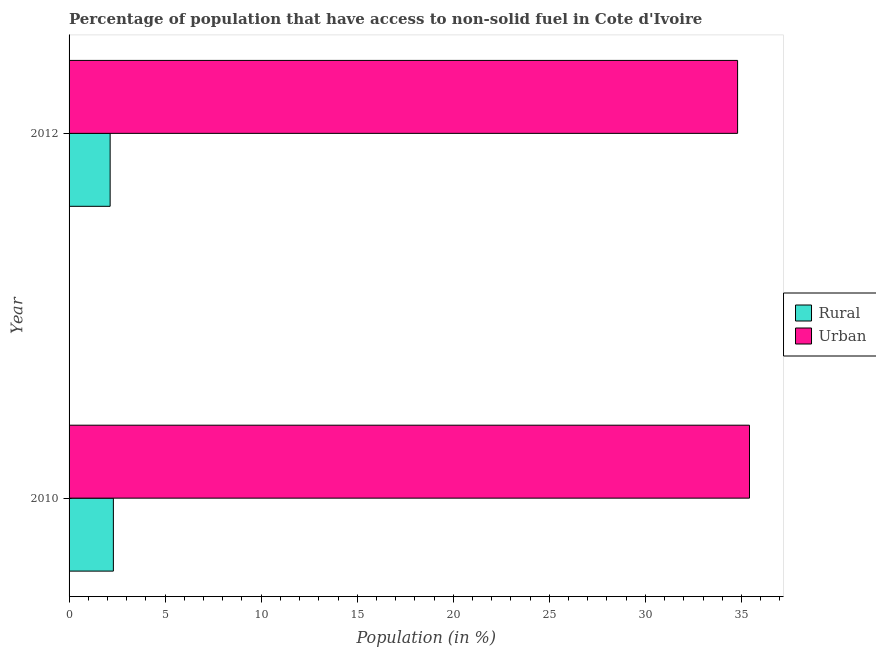Are the number of bars per tick equal to the number of legend labels?
Offer a very short reply. Yes. Are the number of bars on each tick of the Y-axis equal?
Offer a terse response. Yes. How many bars are there on the 1st tick from the top?
Keep it short and to the point. 2. How many bars are there on the 2nd tick from the bottom?
Offer a very short reply. 2. What is the label of the 2nd group of bars from the top?
Give a very brief answer. 2010. What is the urban population in 2012?
Give a very brief answer. 34.8. Across all years, what is the maximum rural population?
Ensure brevity in your answer.  2.31. Across all years, what is the minimum urban population?
Your answer should be compact. 34.8. In which year was the rural population minimum?
Provide a succinct answer. 2012. What is the total rural population in the graph?
Give a very brief answer. 4.44. What is the difference between the urban population in 2010 and that in 2012?
Make the answer very short. 0.62. What is the difference between the urban population in 2010 and the rural population in 2012?
Offer a very short reply. 33.28. What is the average urban population per year?
Provide a short and direct response. 35.11. In the year 2012, what is the difference between the rural population and urban population?
Your answer should be compact. -32.66. What is the ratio of the urban population in 2010 to that in 2012?
Give a very brief answer. 1.02. Is the urban population in 2010 less than that in 2012?
Give a very brief answer. No. Is the difference between the urban population in 2010 and 2012 greater than the difference between the rural population in 2010 and 2012?
Keep it short and to the point. Yes. What does the 2nd bar from the top in 2010 represents?
Give a very brief answer. Rural. What does the 1st bar from the bottom in 2010 represents?
Provide a succinct answer. Rural. How many bars are there?
Ensure brevity in your answer.  4. Are all the bars in the graph horizontal?
Offer a very short reply. Yes. How many years are there in the graph?
Offer a terse response. 2. What is the difference between two consecutive major ticks on the X-axis?
Give a very brief answer. 5. Are the values on the major ticks of X-axis written in scientific E-notation?
Ensure brevity in your answer.  No. Where does the legend appear in the graph?
Offer a terse response. Center right. How are the legend labels stacked?
Provide a succinct answer. Vertical. What is the title of the graph?
Ensure brevity in your answer.  Percentage of population that have access to non-solid fuel in Cote d'Ivoire. Does "Borrowers" appear as one of the legend labels in the graph?
Offer a very short reply. No. What is the label or title of the Y-axis?
Your answer should be very brief. Year. What is the Population (in %) in Rural in 2010?
Make the answer very short. 2.31. What is the Population (in %) of Urban in 2010?
Offer a very short reply. 35.42. What is the Population (in %) of Rural in 2012?
Provide a short and direct response. 2.14. What is the Population (in %) of Urban in 2012?
Offer a terse response. 34.8. Across all years, what is the maximum Population (in %) of Rural?
Your answer should be very brief. 2.31. Across all years, what is the maximum Population (in %) of Urban?
Keep it short and to the point. 35.42. Across all years, what is the minimum Population (in %) of Rural?
Give a very brief answer. 2.14. Across all years, what is the minimum Population (in %) in Urban?
Your response must be concise. 34.8. What is the total Population (in %) of Rural in the graph?
Provide a succinct answer. 4.44. What is the total Population (in %) in Urban in the graph?
Offer a very short reply. 70.22. What is the difference between the Population (in %) in Rural in 2010 and that in 2012?
Give a very brief answer. 0.17. What is the difference between the Population (in %) of Urban in 2010 and that in 2012?
Provide a short and direct response. 0.62. What is the difference between the Population (in %) in Rural in 2010 and the Population (in %) in Urban in 2012?
Provide a succinct answer. -32.49. What is the average Population (in %) in Rural per year?
Provide a succinct answer. 2.22. What is the average Population (in %) of Urban per year?
Provide a short and direct response. 35.11. In the year 2010, what is the difference between the Population (in %) in Rural and Population (in %) in Urban?
Ensure brevity in your answer.  -33.11. In the year 2012, what is the difference between the Population (in %) of Rural and Population (in %) of Urban?
Make the answer very short. -32.66. What is the ratio of the Population (in %) in Rural in 2010 to that in 2012?
Your response must be concise. 1.08. What is the ratio of the Population (in %) of Urban in 2010 to that in 2012?
Offer a terse response. 1.02. What is the difference between the highest and the second highest Population (in %) in Rural?
Provide a short and direct response. 0.17. What is the difference between the highest and the second highest Population (in %) of Urban?
Your answer should be very brief. 0.62. What is the difference between the highest and the lowest Population (in %) of Rural?
Your answer should be compact. 0.17. What is the difference between the highest and the lowest Population (in %) of Urban?
Give a very brief answer. 0.62. 